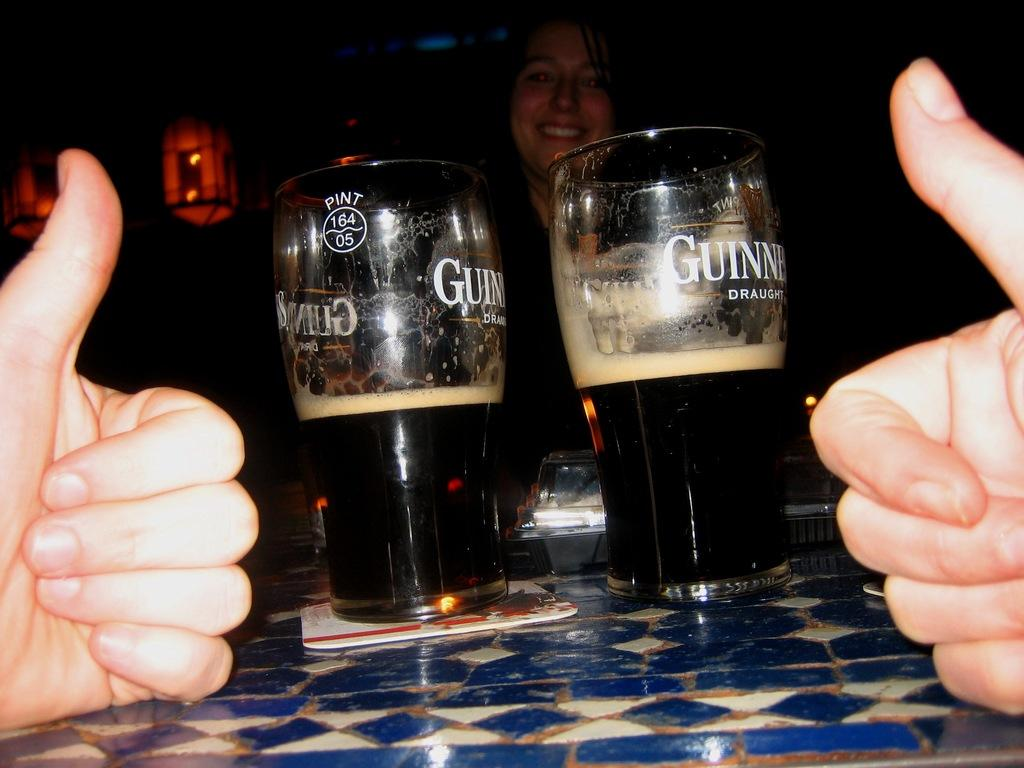<image>
Summarize the visual content of the image. Two hands with a thumbs up are in front of two half full glasses of Guinness Draught beer. 